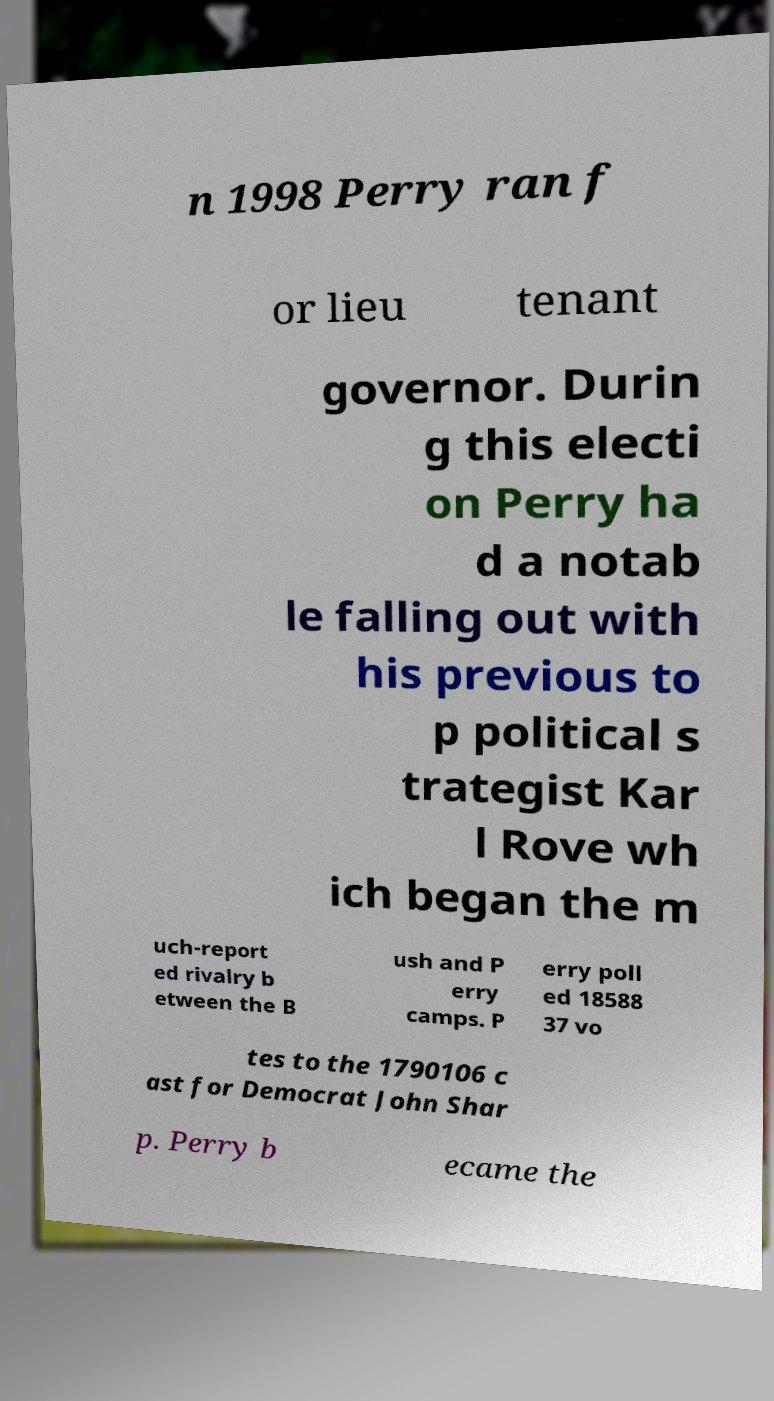For documentation purposes, I need the text within this image transcribed. Could you provide that? n 1998 Perry ran f or lieu tenant governor. Durin g this electi on Perry ha d a notab le falling out with his previous to p political s trategist Kar l Rove wh ich began the m uch-report ed rivalry b etween the B ush and P erry camps. P erry poll ed 18588 37 vo tes to the 1790106 c ast for Democrat John Shar p. Perry b ecame the 